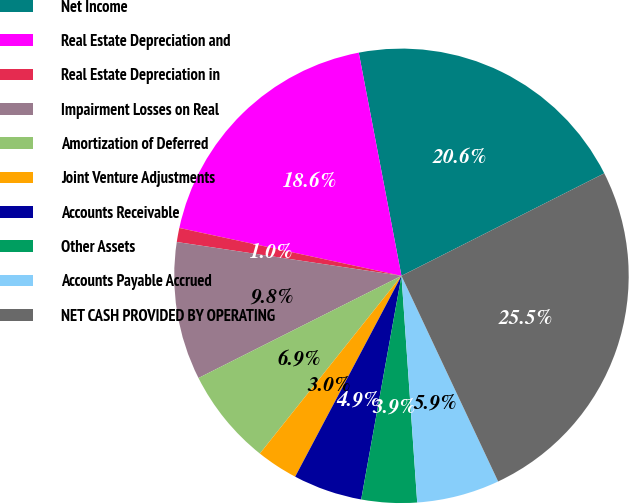Convert chart. <chart><loc_0><loc_0><loc_500><loc_500><pie_chart><fcel>Net Income<fcel>Real Estate Depreciation and<fcel>Real Estate Depreciation in<fcel>Impairment Losses on Real<fcel>Amortization of Deferred<fcel>Joint Venture Adjustments<fcel>Accounts Receivable<fcel>Other Assets<fcel>Accounts Payable Accrued<fcel>NET CASH PROVIDED BY OPERATING<nl><fcel>20.56%<fcel>18.61%<fcel>1.0%<fcel>9.8%<fcel>6.87%<fcel>2.96%<fcel>4.91%<fcel>3.94%<fcel>5.89%<fcel>25.45%<nl></chart> 